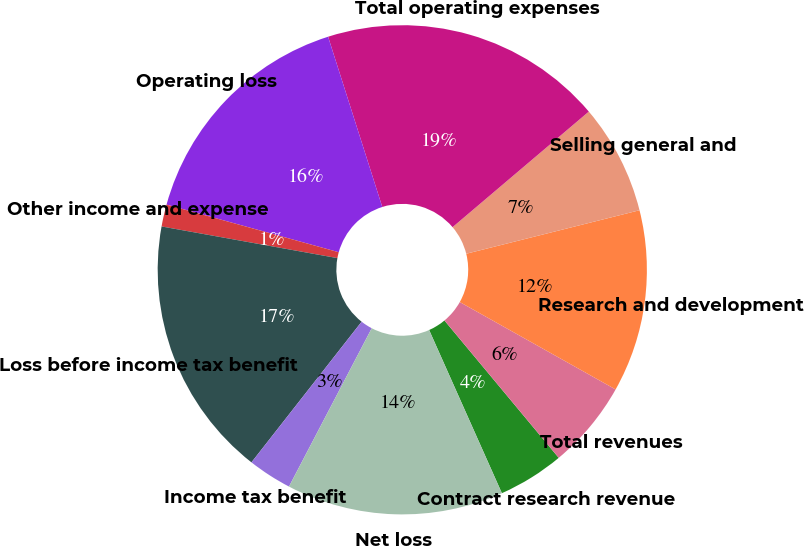Convert chart. <chart><loc_0><loc_0><loc_500><loc_500><pie_chart><fcel>Contract research revenue<fcel>Total revenues<fcel>Research and development<fcel>Selling general and<fcel>Total operating expenses<fcel>Operating loss<fcel>Other income and expense<fcel>Loss before income tax benefit<fcel>Income tax benefit<fcel>Net loss<nl><fcel>4.37%<fcel>5.82%<fcel>12.05%<fcel>7.28%<fcel>18.71%<fcel>15.8%<fcel>1.46%<fcel>17.26%<fcel>2.91%<fcel>14.34%<nl></chart> 